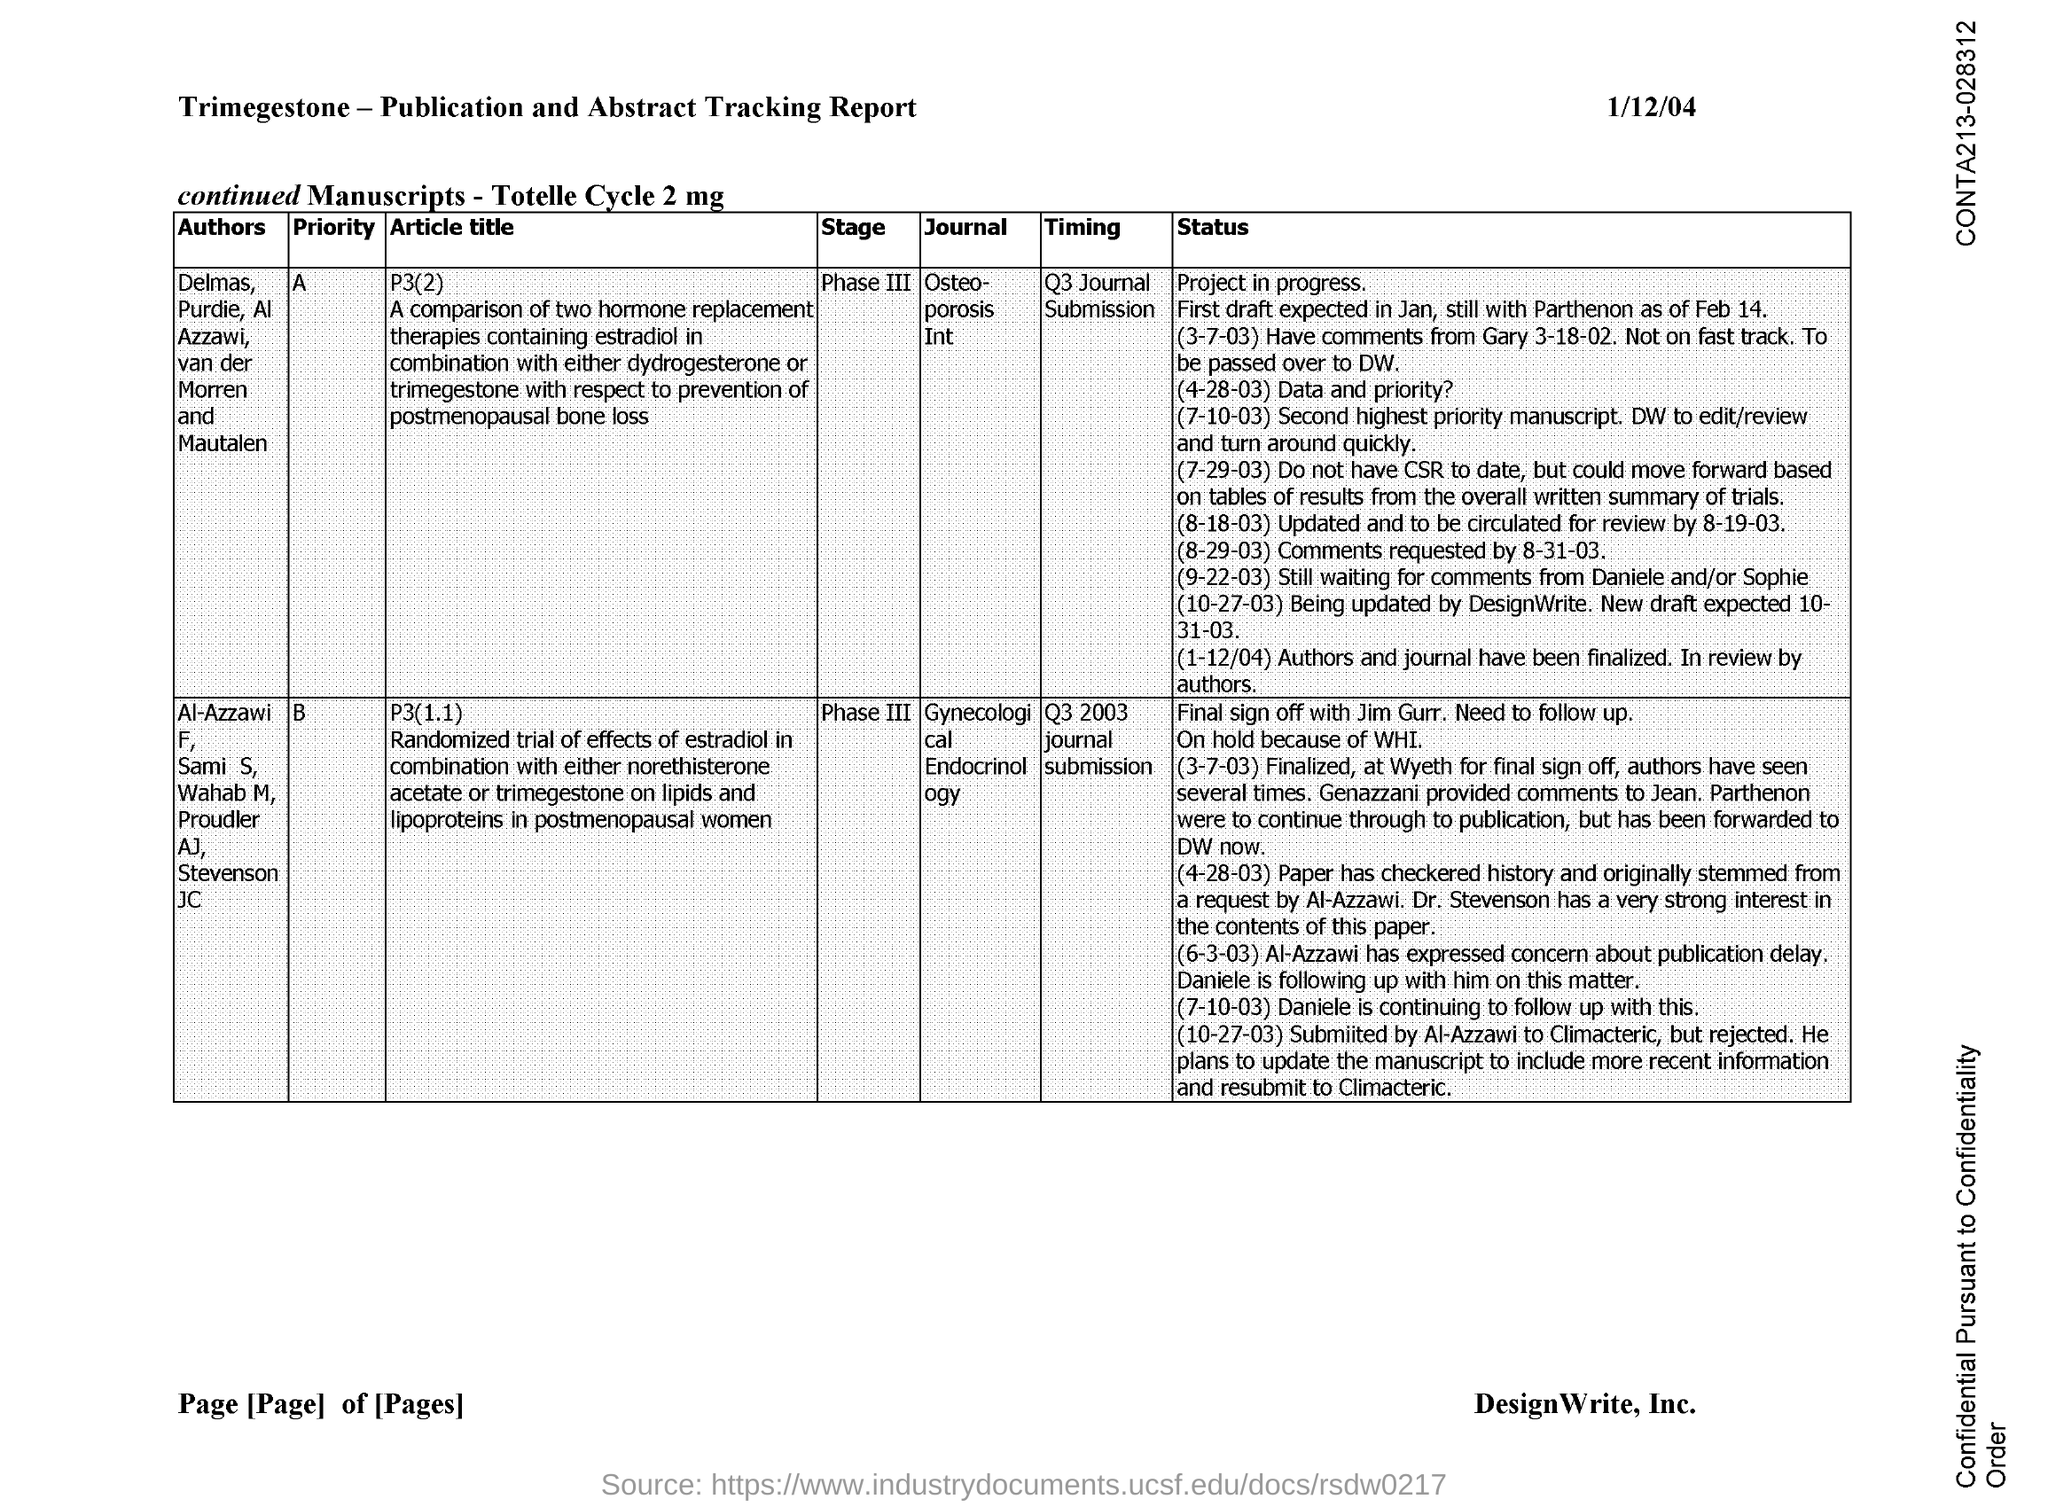What is the Timing for the Journal "Osteoporosis Int"?
Give a very brief answer. Q3 JOURNAL SUBMISSION. What is the Timing for the Journal "Gynecological Endocrinology"?
Provide a succinct answer. Q3 2003 journal submission. 